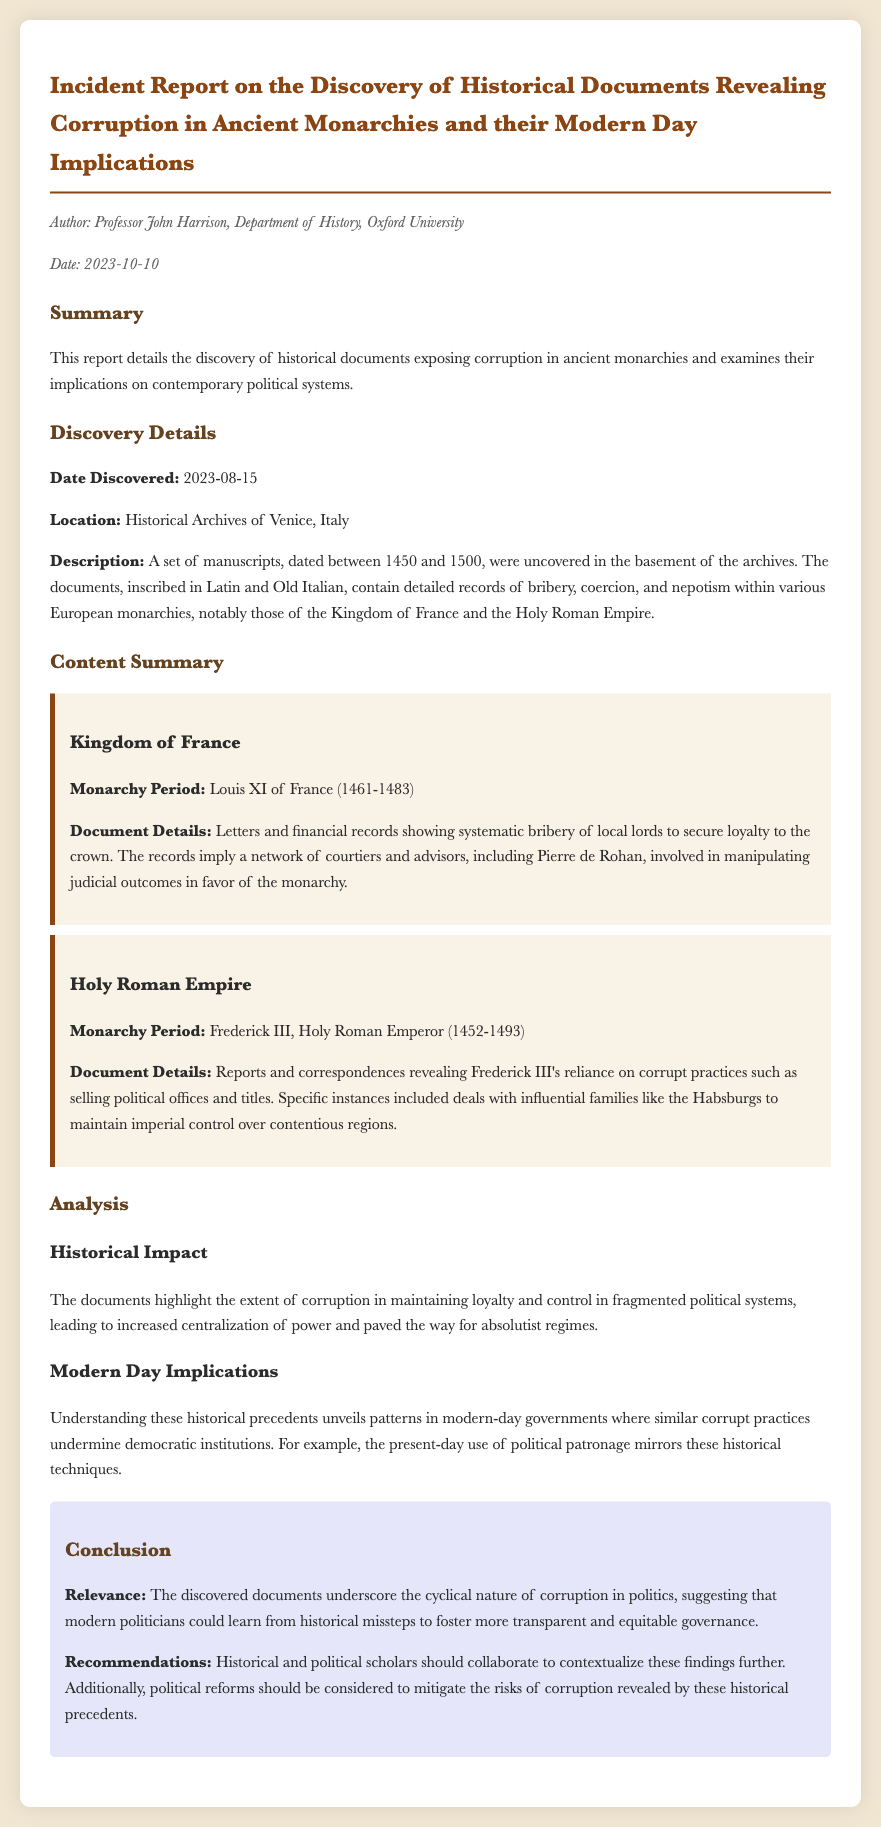What is the author’s name? The author's name is mentioned in the document's meta section as Professor John Harrison.
Answer: Professor John Harrison When were the documents discovered? The date of discovery is specified in the document under "Discovery Details."
Answer: 2023-08-15 What type of corruption is highlighted in the Kingdom of France? The specific type of corruption is outlined in the content summary and includes systematic bribery of local lords.
Answer: Systematic bribery Who was the monarch during the corruption in the Holy Roman Empire? The document lists Frederick III as the monarch during the specified period.
Answer: Frederick III What is one modern-day implication mentioned in the report? The analysis section refers to political patronage as a modern-day implication that mirrors historical practices.
Answer: Political patronage What location was the discovery made in? The place of discovery is detailed in the discovery section of the report.
Answer: Historical Archives of Venice, Italy What period do the manuscripts date back to? The report specifies that the manuscripts are dated between 1450 and 1500.
Answer: 1450 and 1500 What recommendation is made for political reforms? The document suggests collaboration between historical and political scholars as a recommendation.
Answer: Collaboration between scholars 